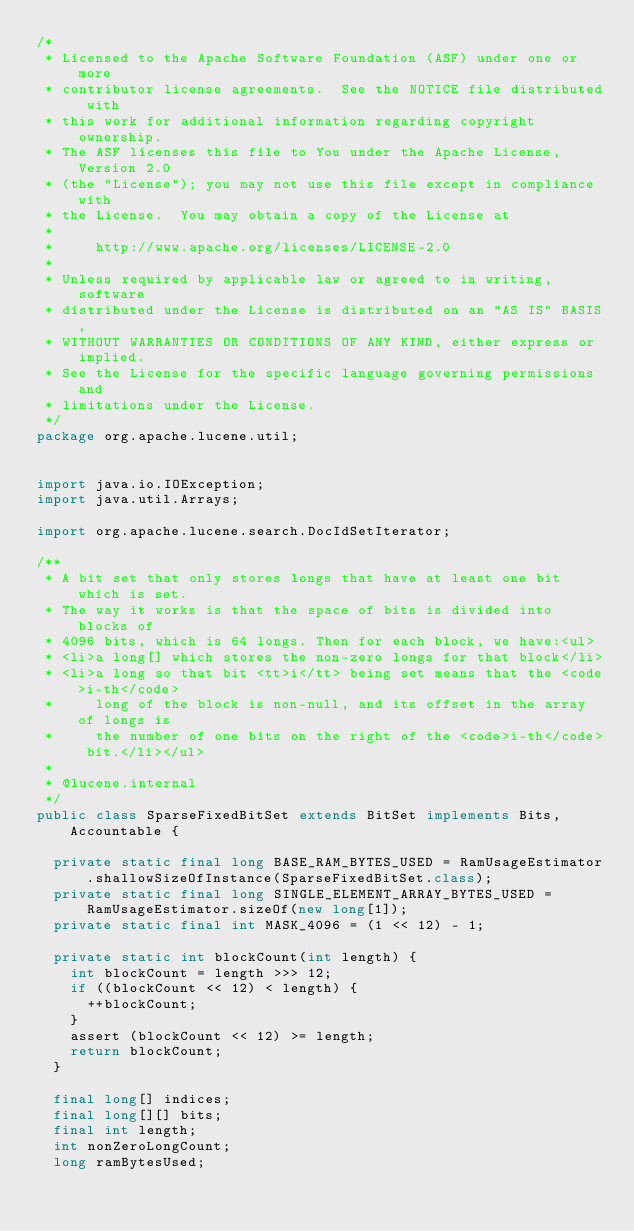Convert code to text. <code><loc_0><loc_0><loc_500><loc_500><_Java_>/*
 * Licensed to the Apache Software Foundation (ASF) under one or more
 * contributor license agreements.  See the NOTICE file distributed with
 * this work for additional information regarding copyright ownership.
 * The ASF licenses this file to You under the Apache License, Version 2.0
 * (the "License"); you may not use this file except in compliance with
 * the License.  You may obtain a copy of the License at
 *
 *     http://www.apache.org/licenses/LICENSE-2.0
 *
 * Unless required by applicable law or agreed to in writing, software
 * distributed under the License is distributed on an "AS IS" BASIS,
 * WITHOUT WARRANTIES OR CONDITIONS OF ANY KIND, either express or implied.
 * See the License for the specific language governing permissions and
 * limitations under the License.
 */
package org.apache.lucene.util;


import java.io.IOException;
import java.util.Arrays;

import org.apache.lucene.search.DocIdSetIterator;

/**
 * A bit set that only stores longs that have at least one bit which is set.
 * The way it works is that the space of bits is divided into blocks of
 * 4096 bits, which is 64 longs. Then for each block, we have:<ul>
 * <li>a long[] which stores the non-zero longs for that block</li>
 * <li>a long so that bit <tt>i</tt> being set means that the <code>i-th</code>
 *     long of the block is non-null, and its offset in the array of longs is
 *     the number of one bits on the right of the <code>i-th</code> bit.</li></ul>
 *
 * @lucene.internal
 */
public class SparseFixedBitSet extends BitSet implements Bits, Accountable {

  private static final long BASE_RAM_BYTES_USED = RamUsageEstimator.shallowSizeOfInstance(SparseFixedBitSet.class);
  private static final long SINGLE_ELEMENT_ARRAY_BYTES_USED = RamUsageEstimator.sizeOf(new long[1]);
  private static final int MASK_4096 = (1 << 12) - 1;

  private static int blockCount(int length) {
    int blockCount = length >>> 12;
    if ((blockCount << 12) < length) {
      ++blockCount;
    }
    assert (blockCount << 12) >= length;
    return blockCount;
  }

  final long[] indices;
  final long[][] bits;
  final int length;
  int nonZeroLongCount;
  long ramBytesUsed;
</code> 